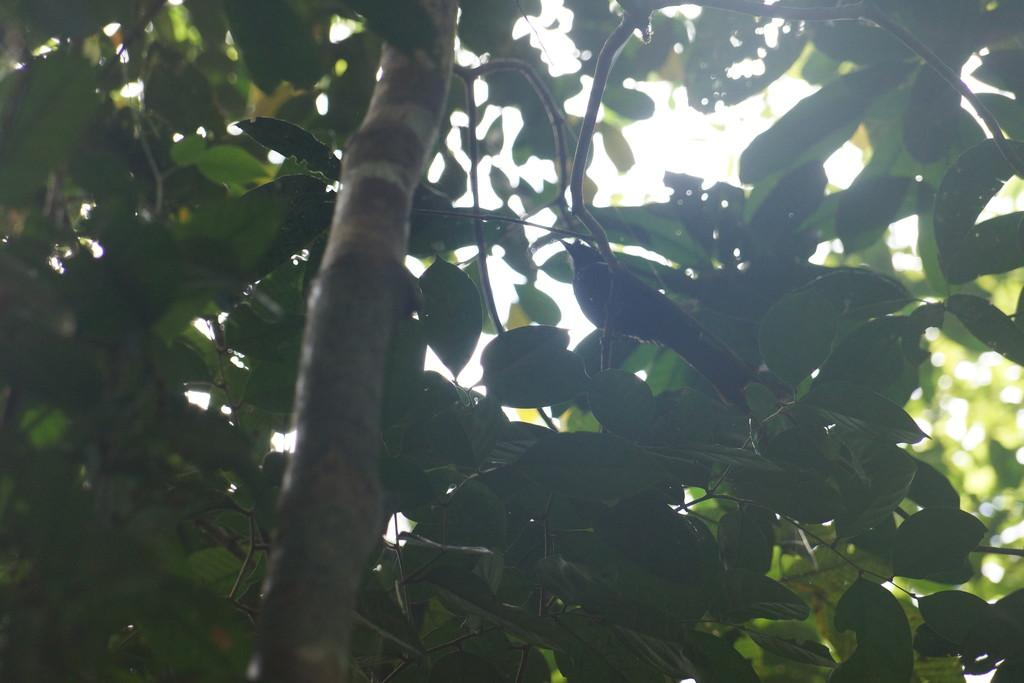What type of animal can be seen in the image? There is a bird in the image. Where is the bird located? The bird is on a branch of a tree. What can be seen around the bird? There are leaves around the bird. What type of business is being conducted by the bird in the image? There is no indication of any business being conducted by the bird in the image. 